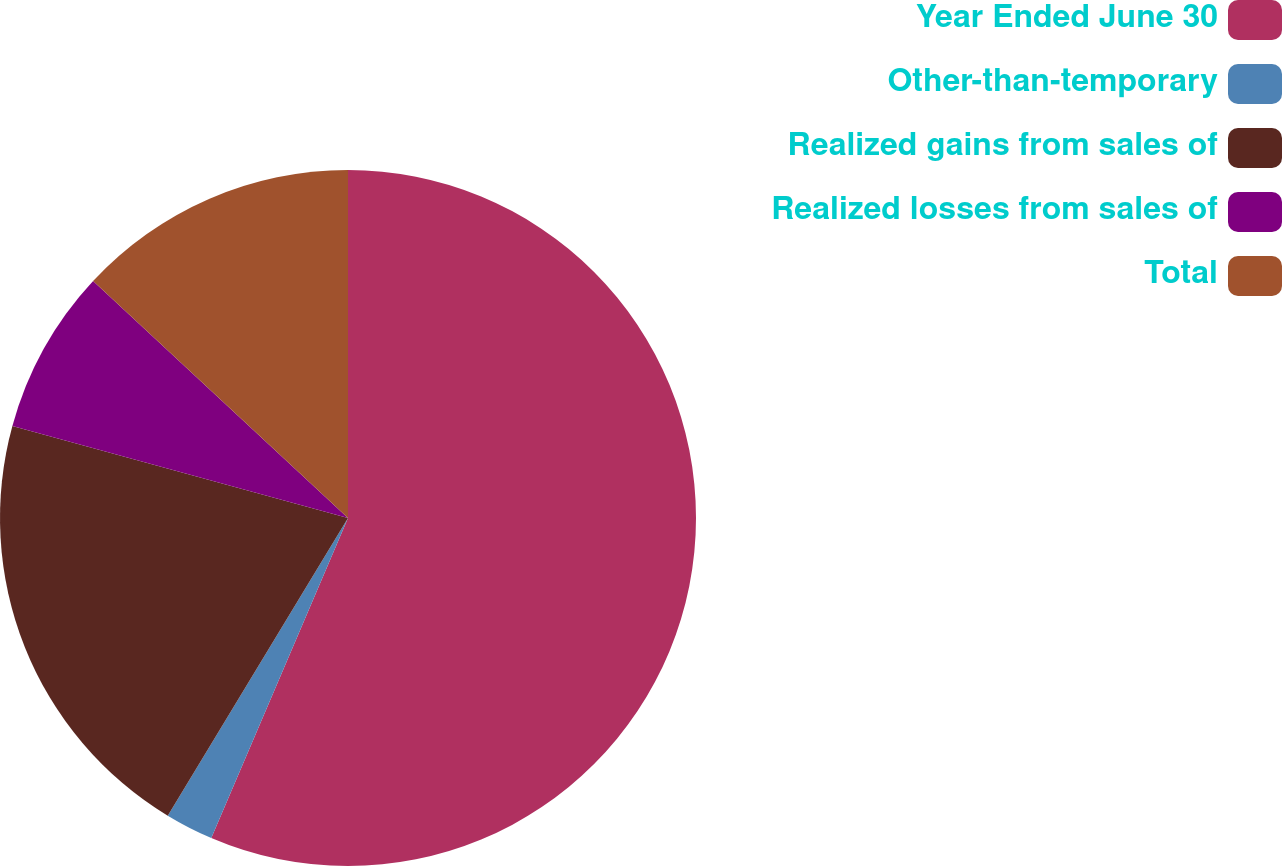Convert chart to OTSL. <chart><loc_0><loc_0><loc_500><loc_500><pie_chart><fcel>Year Ended June 30<fcel>Other-than-temporary<fcel>Realized gains from sales of<fcel>Realized losses from sales of<fcel>Total<nl><fcel>56.42%<fcel>2.24%<fcel>20.59%<fcel>7.66%<fcel>13.08%<nl></chart> 